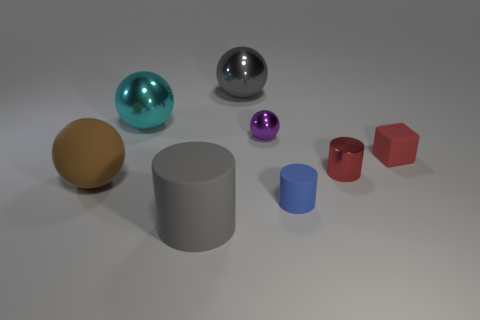Is the color of the small rubber cube the same as the tiny metallic thing to the left of the small rubber cylinder?
Your response must be concise. No. Are there the same number of gray matte cylinders behind the red cube and large cyan spheres that are to the right of the purple metal thing?
Your answer should be very brief. Yes. What number of other things are the same size as the gray ball?
Your answer should be compact. 3. How big is the gray shiny thing?
Keep it short and to the point. Large. Is the material of the cyan object the same as the gray object behind the red rubber cube?
Your answer should be compact. Yes. Is there a green metallic object of the same shape as the small purple object?
Provide a succinct answer. No. What material is the brown thing that is the same size as the gray matte thing?
Your answer should be very brief. Rubber. What size is the red thing in front of the red matte thing?
Provide a succinct answer. Small. There is a cyan metal object left of the small blue matte cylinder; is its size the same as the shiny object that is right of the purple ball?
Your answer should be compact. No. What number of brown objects have the same material as the tiny blue thing?
Make the answer very short. 1. 